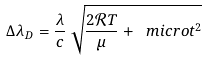<formula> <loc_0><loc_0><loc_500><loc_500>\Delta \lambda _ { D } = \frac { \lambda } { c } \, \sqrt { \frac { 2 \mathcal { R } T } { \mu } + \ m i c r o t ^ { 2 } }</formula> 